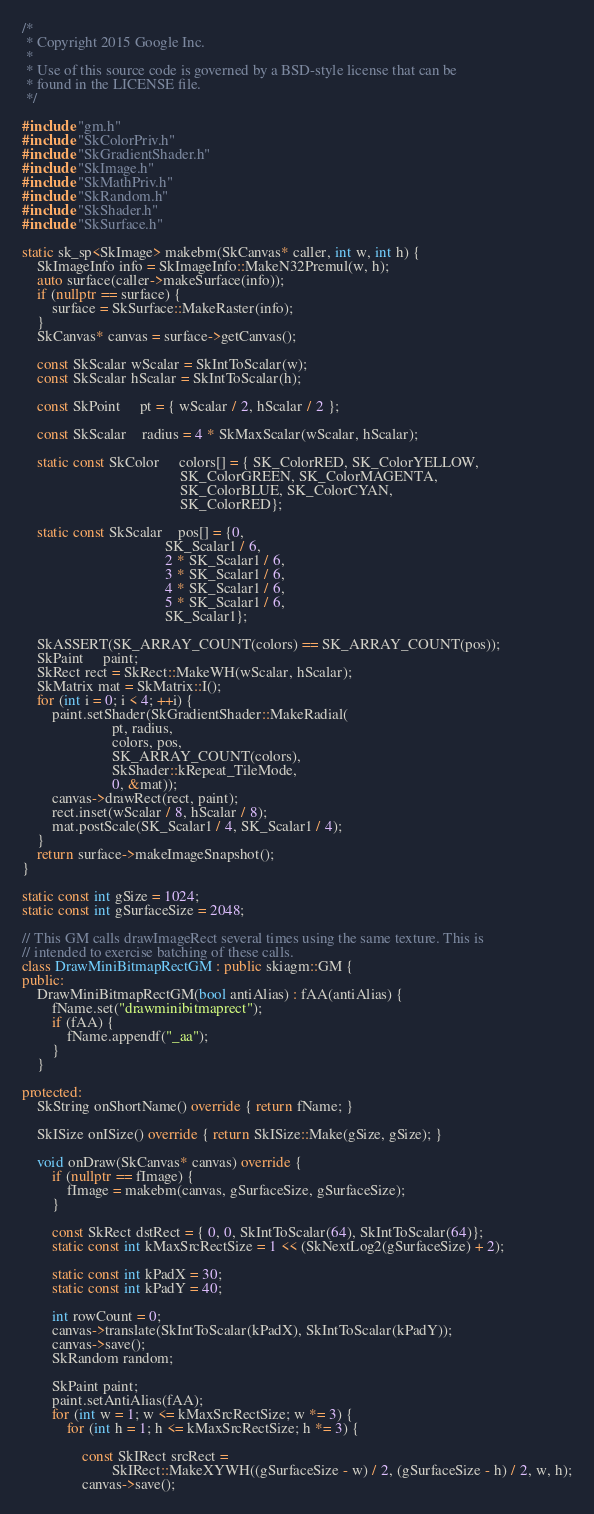<code> <loc_0><loc_0><loc_500><loc_500><_C++_>/*
 * Copyright 2015 Google Inc.
 *
 * Use of this source code is governed by a BSD-style license that can be
 * found in the LICENSE file.
 */

#include "gm.h"
#include "SkColorPriv.h"
#include "SkGradientShader.h"
#include "SkImage.h"
#include "SkMathPriv.h"
#include "SkRandom.h"
#include "SkShader.h"
#include "SkSurface.h"

static sk_sp<SkImage> makebm(SkCanvas* caller, int w, int h) {
    SkImageInfo info = SkImageInfo::MakeN32Premul(w, h);
    auto surface(caller->makeSurface(info));
    if (nullptr == surface) {
        surface = SkSurface::MakeRaster(info);
    }
    SkCanvas* canvas = surface->getCanvas();

    const SkScalar wScalar = SkIntToScalar(w);
    const SkScalar hScalar = SkIntToScalar(h);

    const SkPoint     pt = { wScalar / 2, hScalar / 2 };

    const SkScalar    radius = 4 * SkMaxScalar(wScalar, hScalar);

    static const SkColor     colors[] = { SK_ColorRED, SK_ColorYELLOW,
                                          SK_ColorGREEN, SK_ColorMAGENTA,
                                          SK_ColorBLUE, SK_ColorCYAN,
                                          SK_ColorRED};

    static const SkScalar    pos[] = {0,
                                      SK_Scalar1 / 6,
                                      2 * SK_Scalar1 / 6,
                                      3 * SK_Scalar1 / 6,
                                      4 * SK_Scalar1 / 6,
                                      5 * SK_Scalar1 / 6,
                                      SK_Scalar1};

    SkASSERT(SK_ARRAY_COUNT(colors) == SK_ARRAY_COUNT(pos));
    SkPaint     paint;
    SkRect rect = SkRect::MakeWH(wScalar, hScalar);
    SkMatrix mat = SkMatrix::I();
    for (int i = 0; i < 4; ++i) {
        paint.setShader(SkGradientShader::MakeRadial(
                        pt, radius,
                        colors, pos,
                        SK_ARRAY_COUNT(colors),
                        SkShader::kRepeat_TileMode,
                        0, &mat));
        canvas->drawRect(rect, paint);
        rect.inset(wScalar / 8, hScalar / 8);
        mat.postScale(SK_Scalar1 / 4, SK_Scalar1 / 4);
    }
    return surface->makeImageSnapshot();
}

static const int gSize = 1024;
static const int gSurfaceSize = 2048;

// This GM calls drawImageRect several times using the same texture. This is
// intended to exercise batching of these calls.
class DrawMiniBitmapRectGM : public skiagm::GM {
public:
    DrawMiniBitmapRectGM(bool antiAlias) : fAA(antiAlias) {
        fName.set("drawminibitmaprect");
        if (fAA) {
            fName.appendf("_aa");
        }
    }

protected:
    SkString onShortName() override { return fName; }

    SkISize onISize() override { return SkISize::Make(gSize, gSize); }

    void onDraw(SkCanvas* canvas) override {
        if (nullptr == fImage) {
            fImage = makebm(canvas, gSurfaceSize, gSurfaceSize);
        }

        const SkRect dstRect = { 0, 0, SkIntToScalar(64), SkIntToScalar(64)};
        static const int kMaxSrcRectSize = 1 << (SkNextLog2(gSurfaceSize) + 2);

        static const int kPadX = 30;
        static const int kPadY = 40;

        int rowCount = 0;
        canvas->translate(SkIntToScalar(kPadX), SkIntToScalar(kPadY));
        canvas->save();
        SkRandom random;

        SkPaint paint;
        paint.setAntiAlias(fAA);
        for (int w = 1; w <= kMaxSrcRectSize; w *= 3) {
            for (int h = 1; h <= kMaxSrcRectSize; h *= 3) {

                const SkIRect srcRect =
                        SkIRect::MakeXYWH((gSurfaceSize - w) / 2, (gSurfaceSize - h) / 2, w, h);
                canvas->save();</code> 